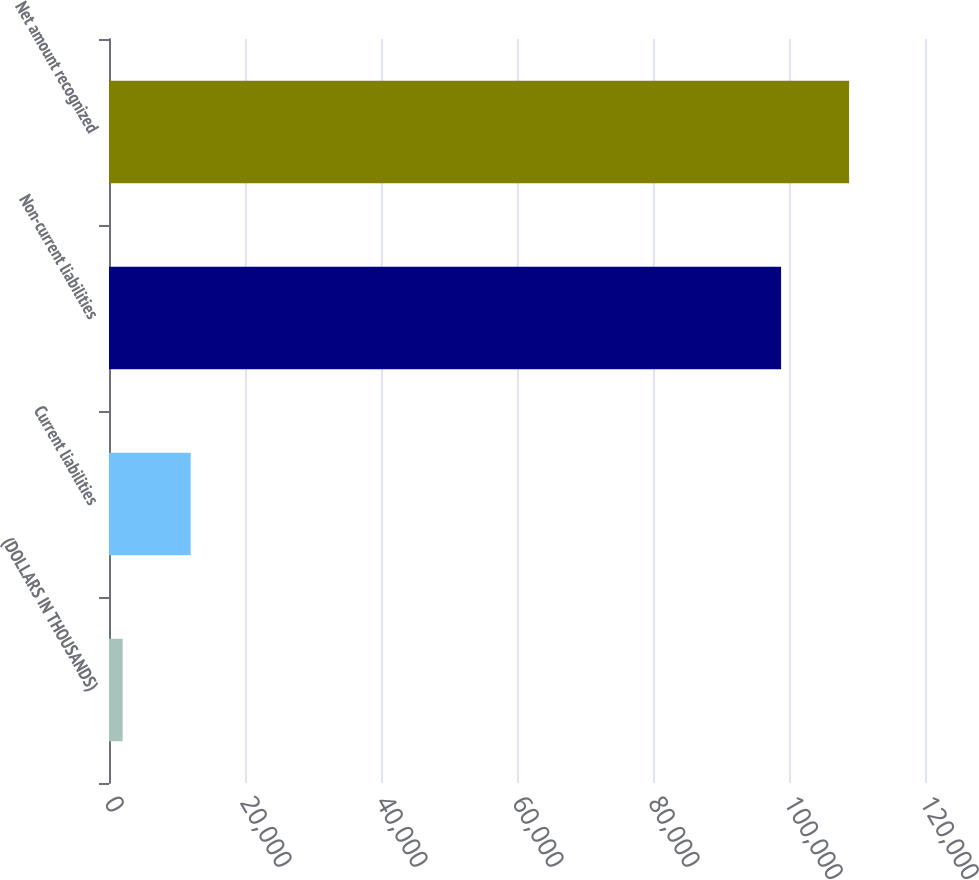Convert chart to OTSL. <chart><loc_0><loc_0><loc_500><loc_500><bar_chart><fcel>(DOLLARS IN THOUSANDS)<fcel>Current liabilities<fcel>Non-current liabilities<fcel>Net amount recognized<nl><fcel>2009<fcel>12009.2<fcel>98836<fcel>108836<nl></chart> 